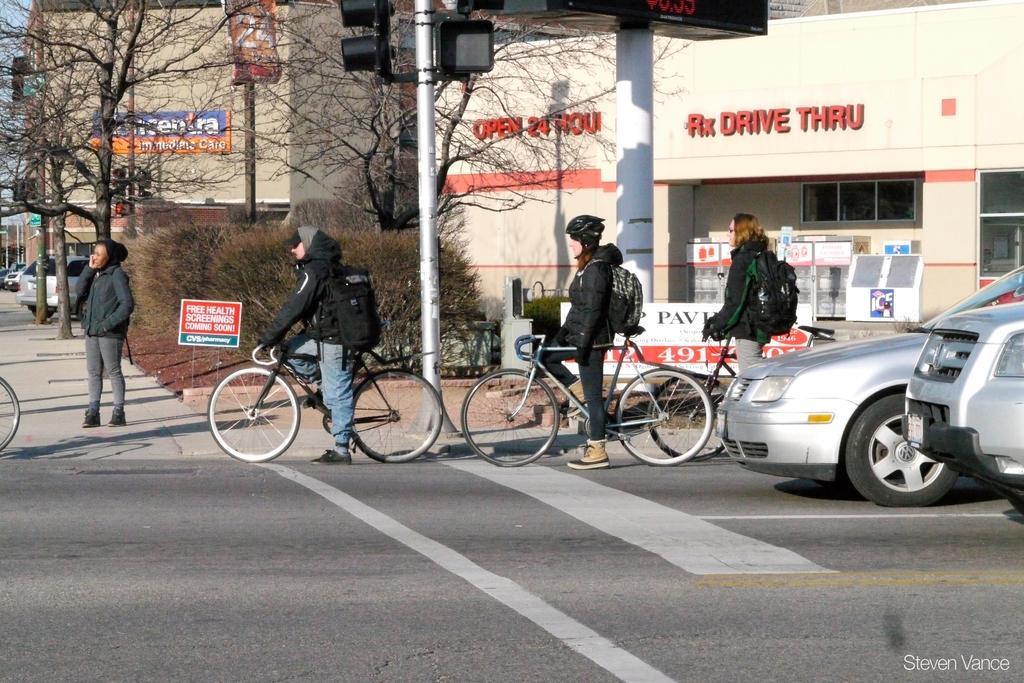Please provide a concise description of this image. In this picture I can see group of people standing, there are vehicles on the road, there are lights, poles, boards, plants, trees, buildings, and there is a watermark on the image. 